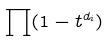Convert formula to latex. <formula><loc_0><loc_0><loc_500><loc_500>\prod ( 1 - t ^ { d _ { i } } )</formula> 